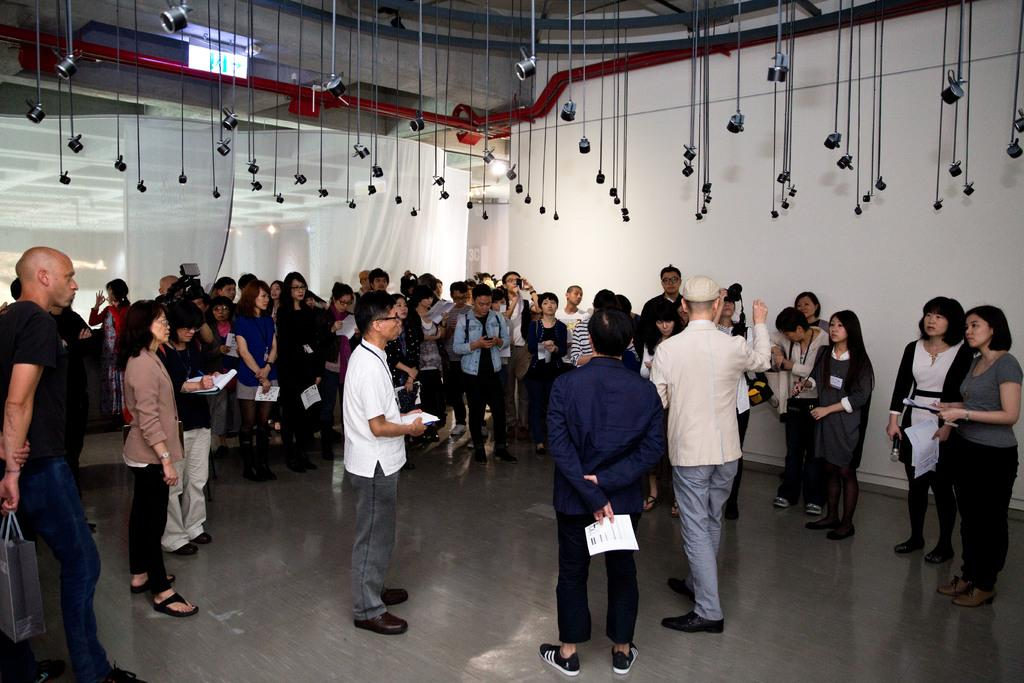How many people are in the image? There are people in the image, but the exact number is not specified. What are some of the people holding in the image? Some of the people are holding papers in the image. What can be seen in the background of the image? There is a wall in the background of the image. What type of window treatment is present in the image? There are curtains in the image. What is visible at the bottom of the image? The floor is visible at the bottom of the image. How many socks are visible on the fifth person in the image? There is no mention of socks or a fifth person in the image. 